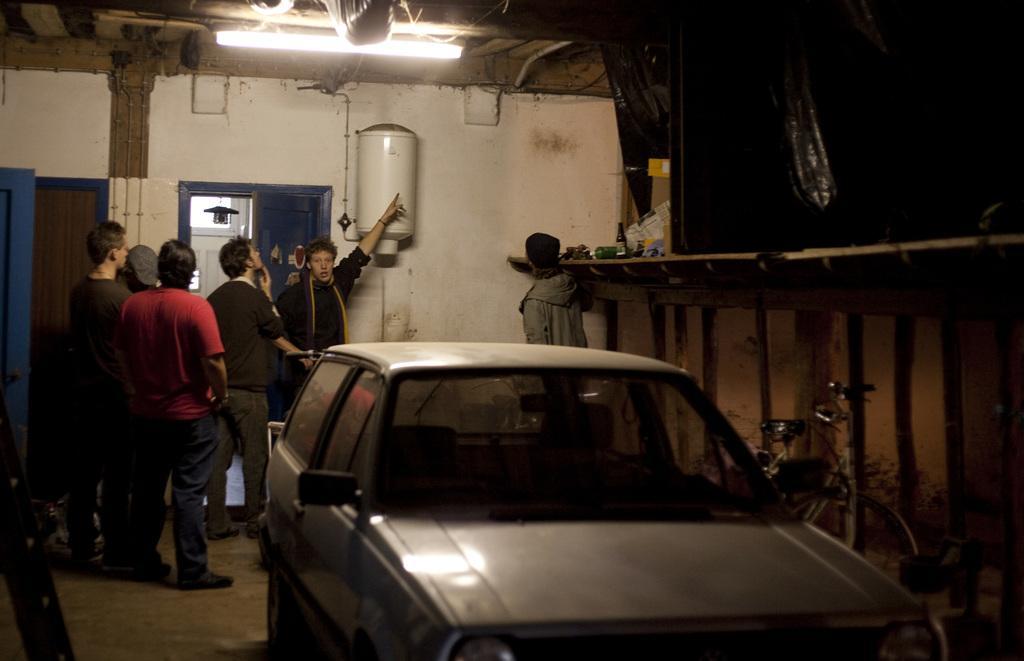Could you give a brief overview of what you see in this image? In this image, on the left side, we can see a group of people standing. In the middle of the image, we can see a car. On the right side, we can see a bicycle, wall and a person, table, on that table, we can see some bottles and some instrument. On the right side, we can see black color. In the background, we can also see a group of people, door and an electronic instrument. At the top, we can see a roof with tubelight. 